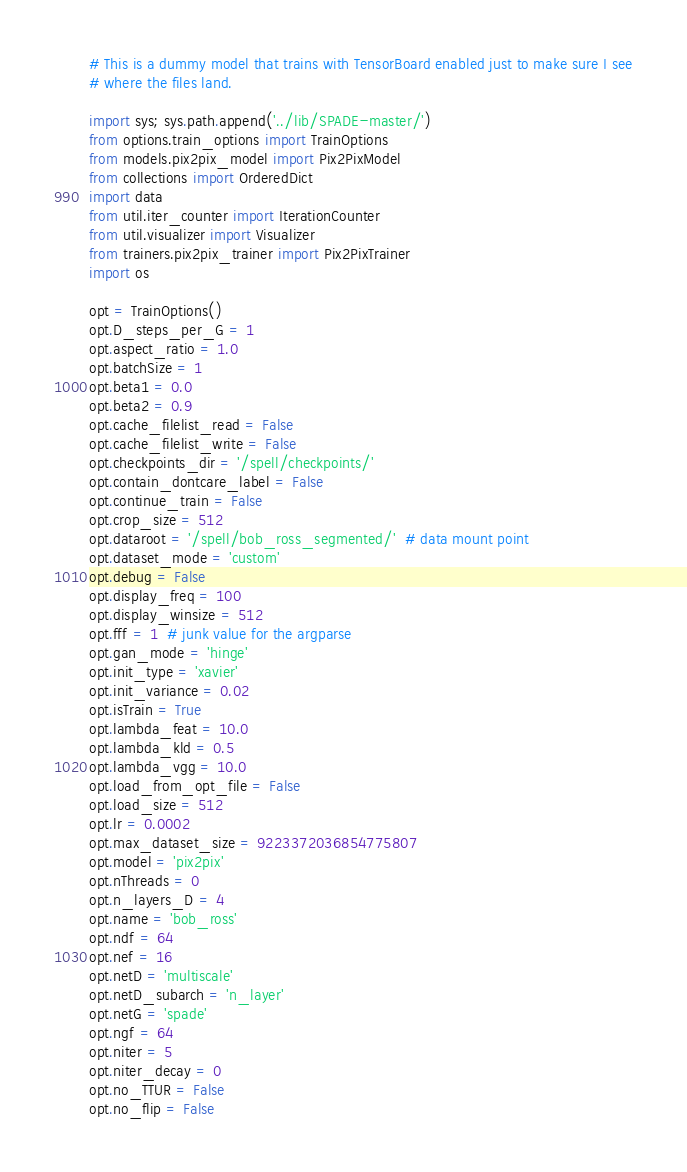<code> <loc_0><loc_0><loc_500><loc_500><_Python_># This is a dummy model that trains with TensorBoard enabled just to make sure I see
# where the files land.

import sys; sys.path.append('../lib/SPADE-master/')
from options.train_options import TrainOptions
from models.pix2pix_model import Pix2PixModel
from collections import OrderedDict
import data
from util.iter_counter import IterationCounter
from util.visualizer import Visualizer
from trainers.pix2pix_trainer import Pix2PixTrainer
import os

opt = TrainOptions()
opt.D_steps_per_G = 1
opt.aspect_ratio = 1.0
opt.batchSize = 1
opt.beta1 = 0.0
opt.beta2 = 0.9
opt.cache_filelist_read = False
opt.cache_filelist_write = False
opt.checkpoints_dir = '/spell/checkpoints/'
opt.contain_dontcare_label = False
opt.continue_train = False
opt.crop_size = 512
opt.dataroot = '/spell/bob_ross_segmented/'  # data mount point
opt.dataset_mode = 'custom'
opt.debug = False
opt.display_freq = 100
opt.display_winsize = 512
opt.fff = 1  # junk value for the argparse
opt.gan_mode = 'hinge'
opt.init_type = 'xavier'
opt.init_variance = 0.02
opt.isTrain = True
opt.lambda_feat = 10.0
opt.lambda_kld = 0.5
opt.lambda_vgg = 10.0
opt.load_from_opt_file = False
opt.load_size = 512
opt.lr = 0.0002
opt.max_dataset_size = 9223372036854775807
opt.model = 'pix2pix'
opt.nThreads = 0
opt.n_layers_D = 4
opt.name = 'bob_ross'
opt.ndf = 64
opt.nef = 16
opt.netD = 'multiscale'
opt.netD_subarch = 'n_layer'
opt.netG = 'spade'
opt.ngf = 64
opt.niter = 5
opt.niter_decay = 0
opt.no_TTUR = False
opt.no_flip = False</code> 